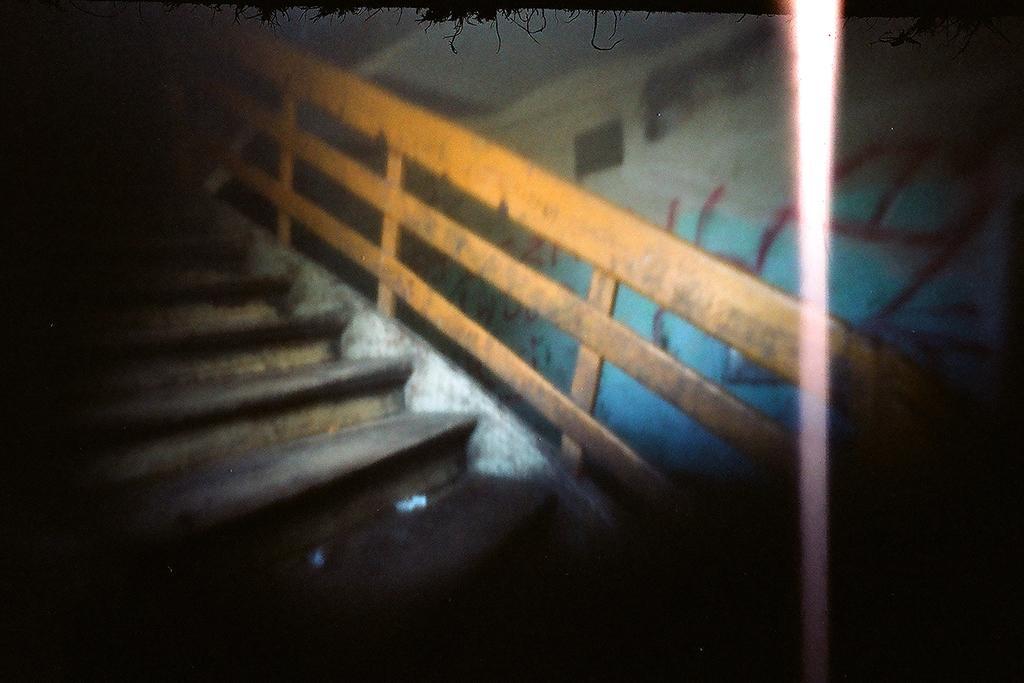Please provide a concise description of this image. In this image there is a staircase in the middle. On the right side there is a wall on which there is a painting. 